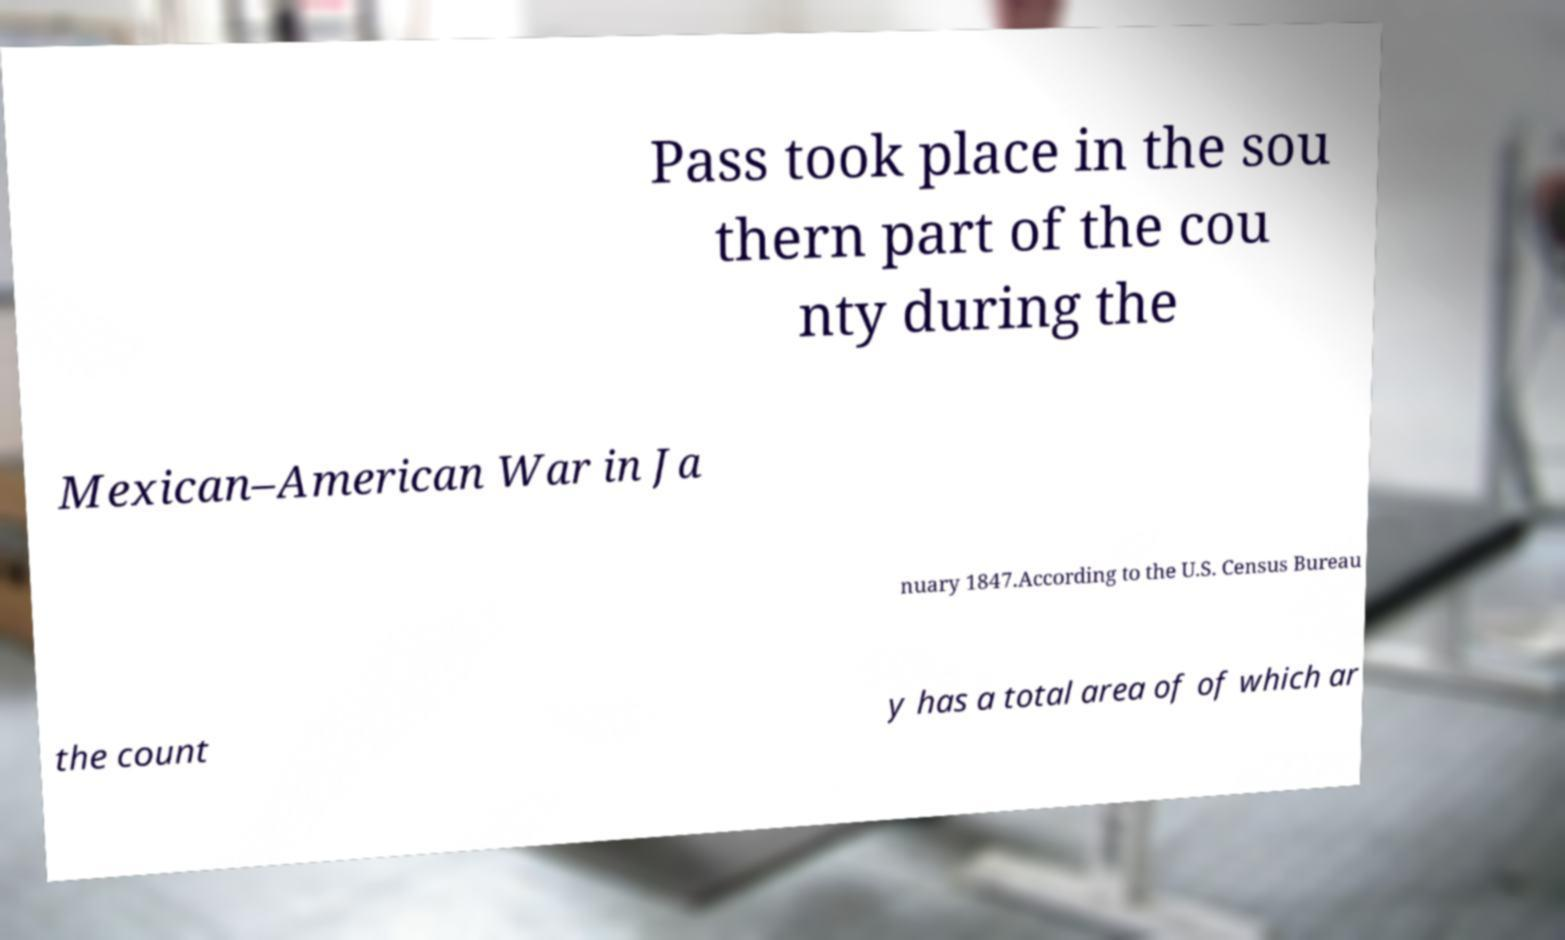Please identify and transcribe the text found in this image. Pass took place in the sou thern part of the cou nty during the Mexican–American War in Ja nuary 1847.According to the U.S. Census Bureau the count y has a total area of of which ar 